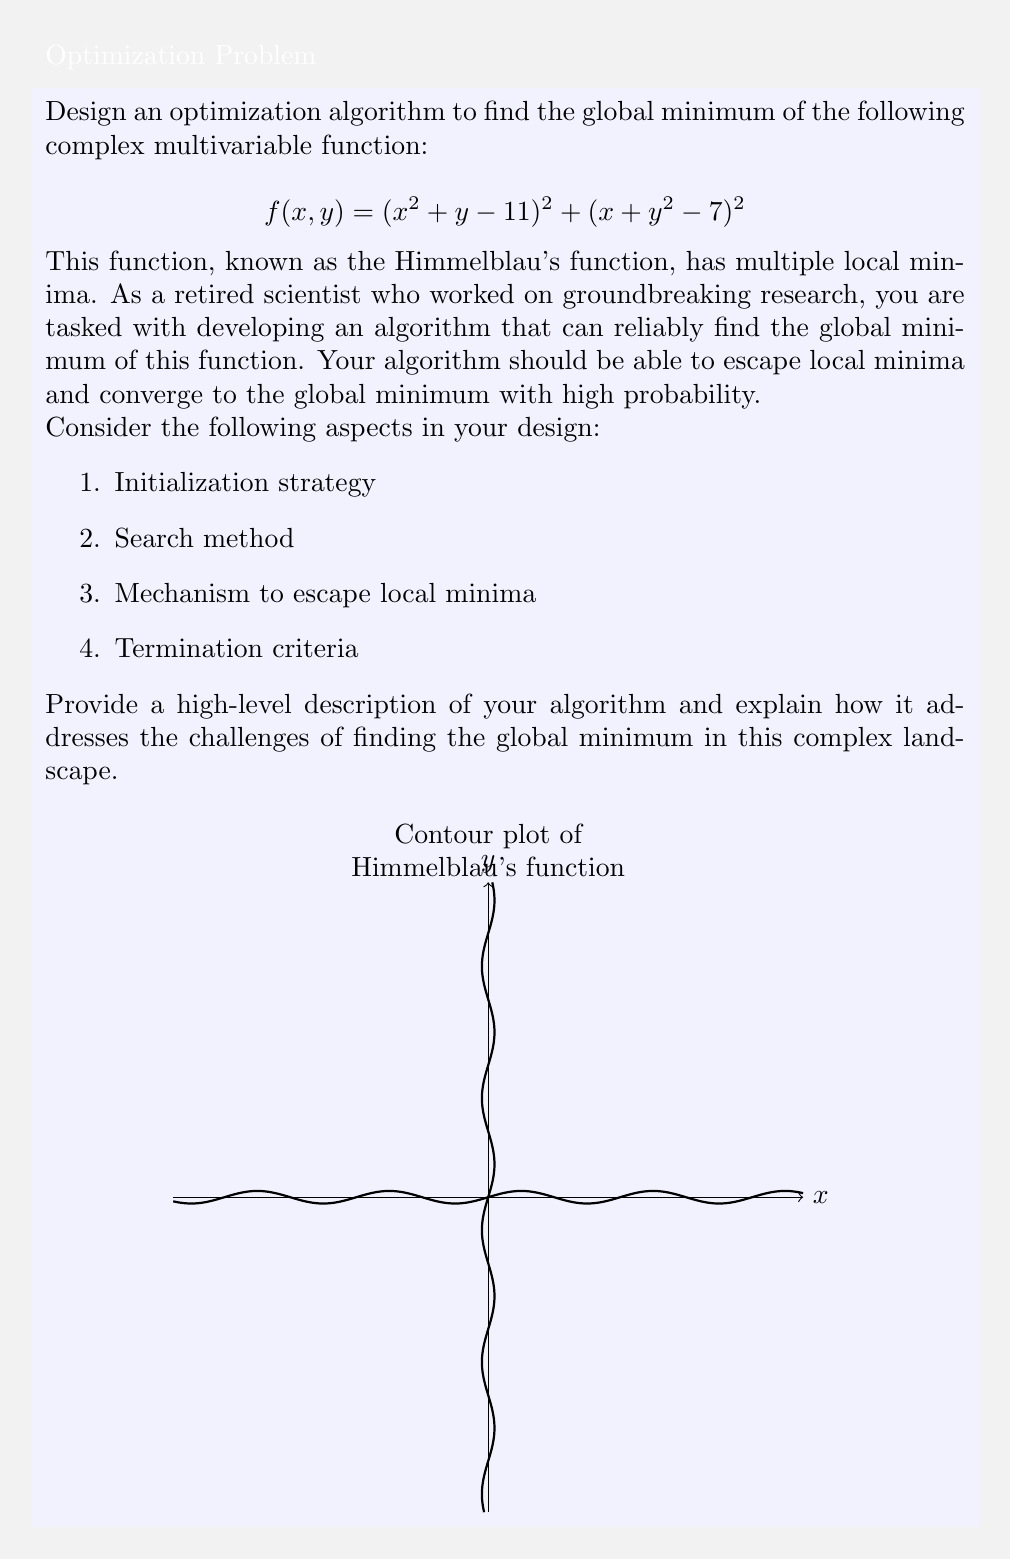Give your solution to this math problem. To design an optimization algorithm for finding the global minimum of Himmelblau's function, we can use a hybrid approach combining global and local search methods. Here's a step-by-step explanation of the proposed algorithm:

1. Initialization:
   - Use a Latin Hypercube Sampling (LHS) method to generate a diverse set of initial points across the search space. This ensures a good coverage of the function landscape.

2. Global Search:
   - Implement a Particle Swarm Optimization (PSO) algorithm:
     a. Initialize particles with positions from LHS and random velocities.
     b. Update particle positions and velocities based on personal and global best solutions.
     c. Evaluate the function at each particle's position.

3. Local Search:
   - Apply the Nelder-Mead simplex method to the best solutions found by PSO:
     a. Form a simplex around each promising solution.
     b. Perform reflection, expansion, contraction, and shrinkage operations to move towards the local minimum.

4. Escaping Local Minima:
   - Implement a simulated annealing-like approach:
     a. Occasionally accept worse solutions with a probability that decreases over time.
     b. This allows the algorithm to escape local minima and explore other regions.

5. Termination Criteria:
   - Set a maximum number of function evaluations or iterations.
   - Stop if the improvement in the best solution is below a threshold for a certain number of iterations.

6. Refinement:
   - Apply a gradient-based method (e.g., L-BFGS) to the best solution found for final refinement.

The algorithm works as follows:

1. Generate initial population using LHS.
2. Run PSO for a fixed number of iterations.
3. Select the top N solutions from PSO.
4. For each selected solution:
   a. Apply Nelder-Mead simplex method.
   b. Occasionally accept worse solutions (simulated annealing).
5. Update the best solution found.
6. Repeat steps 2-5 until termination criteria are met.
7. Apply L-BFGS to the best solution for final refinement.

This hybrid approach combines the global exploration capabilities of PSO with the local exploitation strengths of Nelder-Mead and L-BFGS. The simulated annealing-like mechanism helps in escaping local minima, increasing the probability of finding the global minimum.

The global minimum of Himmelblau's function occurs at four points:
$$(3, 2), (-2.805118, 3.131312), (-3.779310, -3.283186), (3.584428, -1.848126)$$

All these points have a function value of 0, which is the global minimum.
Answer: Hybrid PSO-Nelder-Mead-SA algorithm with L-BFGS refinement 